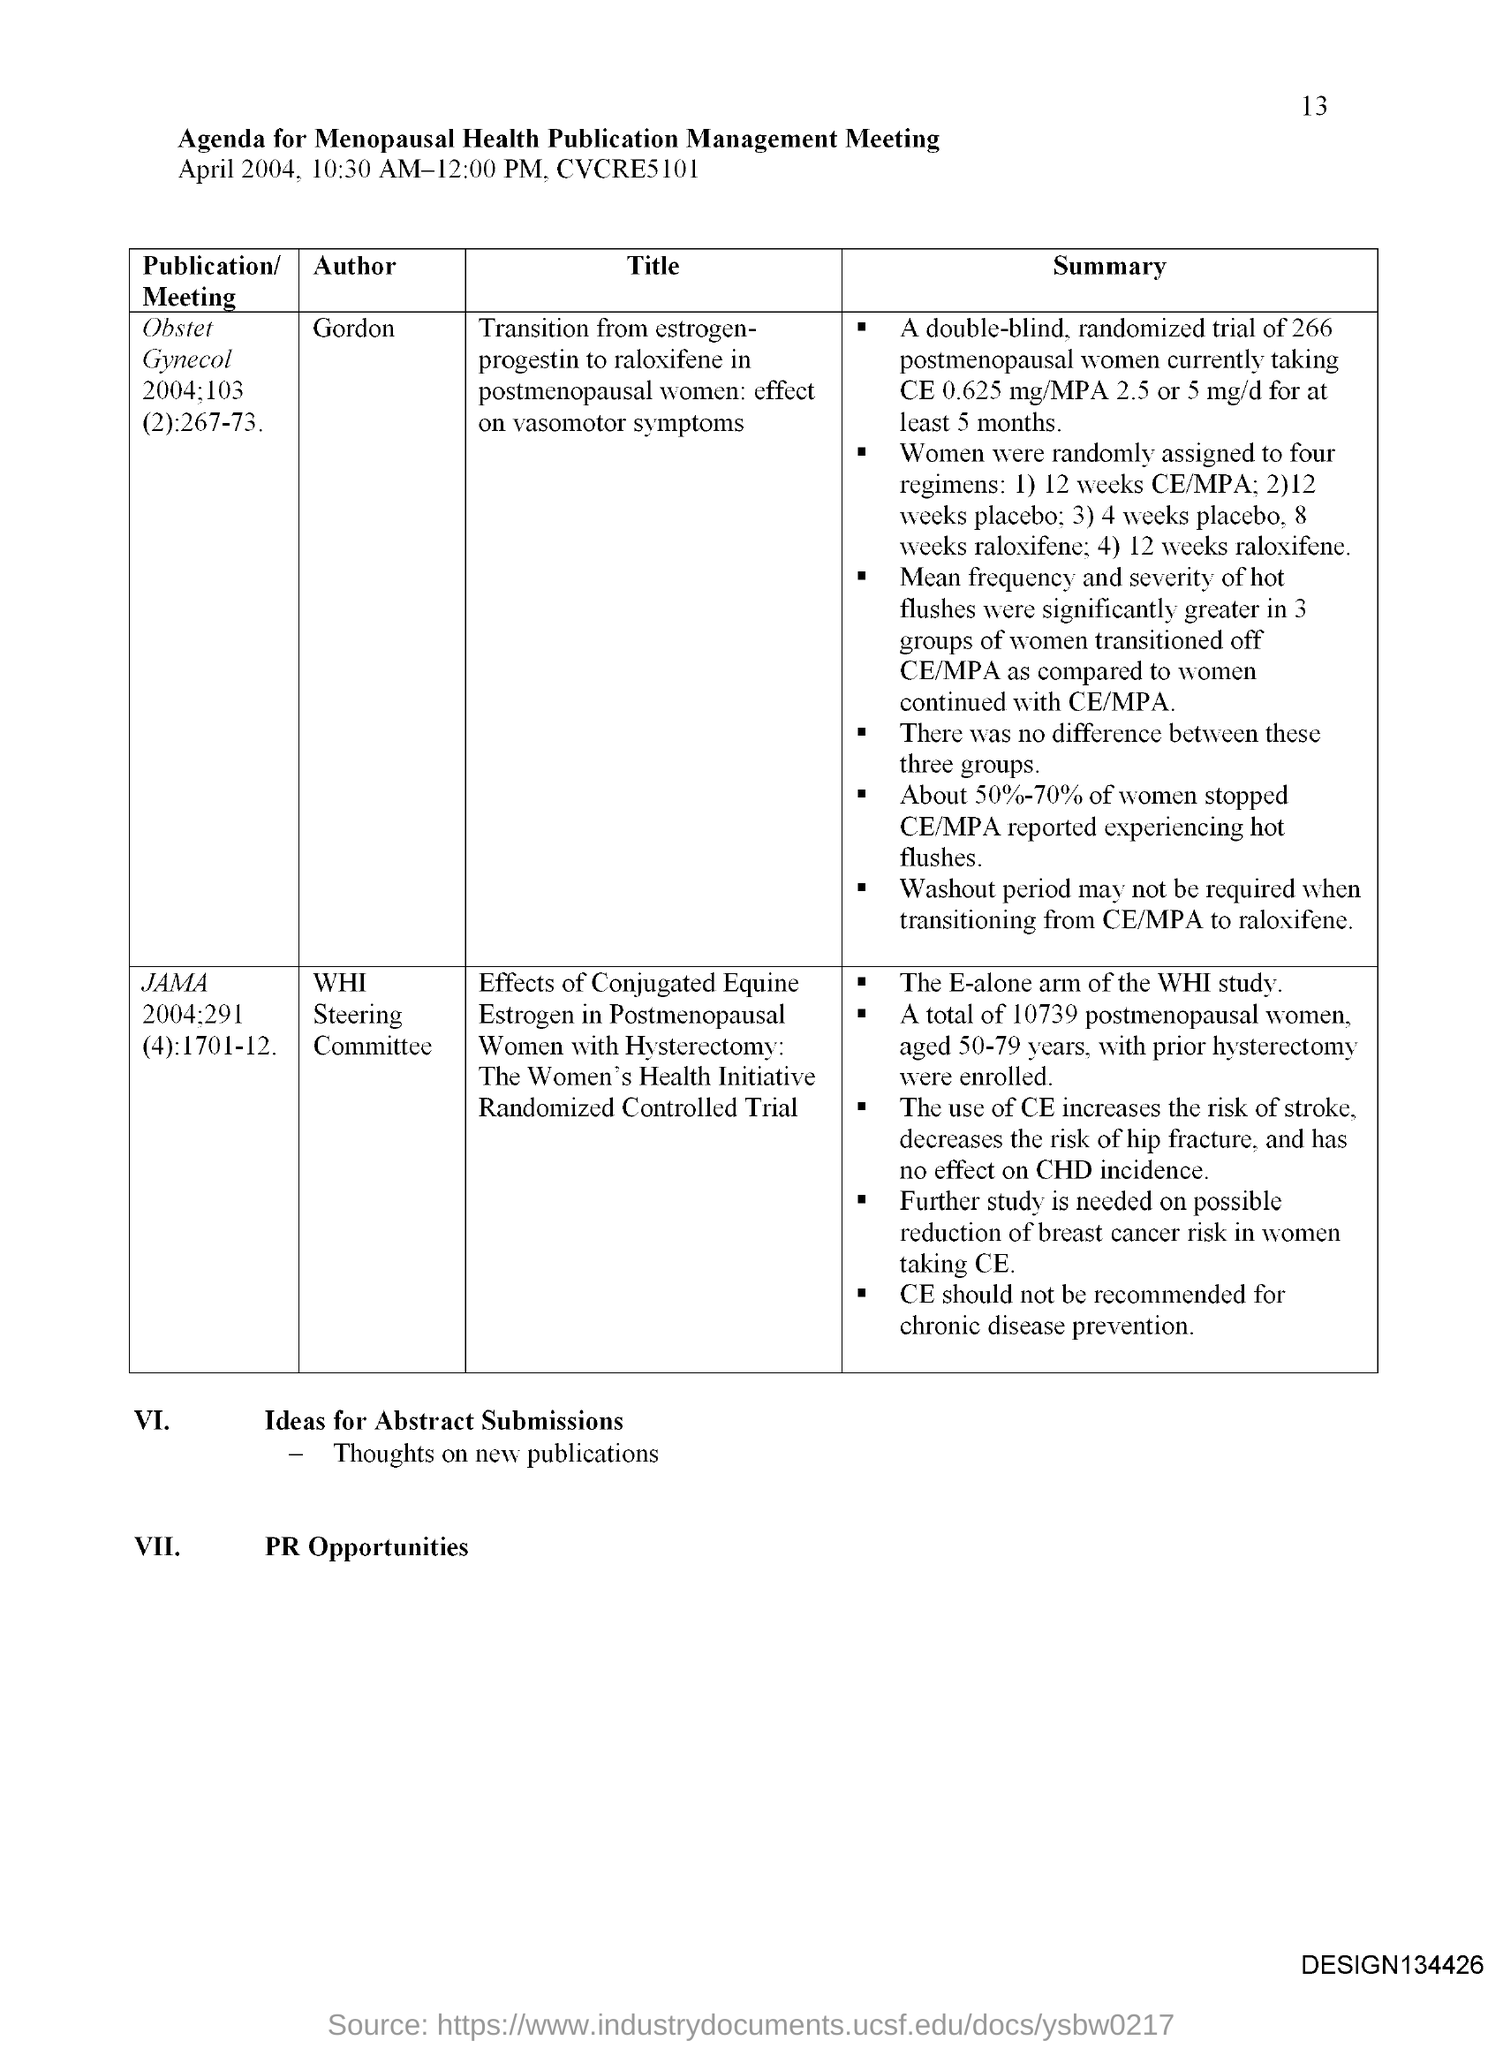Specify some key components in this picture. The document pertains to a meeting agenda for the management of publications related to menopausal health. The page number mentioned in this document is 13. 